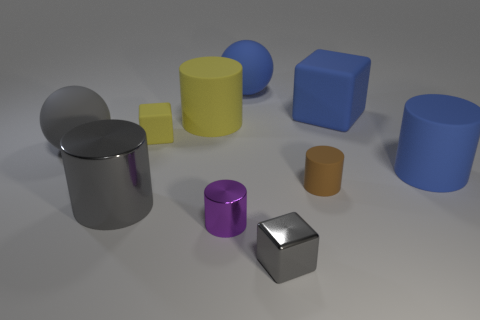Subtract all red cylinders. Subtract all green blocks. How many cylinders are left? 5 Subtract all balls. How many objects are left? 8 Add 1 large yellow cylinders. How many large yellow cylinders exist? 2 Subtract 1 blue blocks. How many objects are left? 9 Subtract all big metal cubes. Subtract all yellow rubber objects. How many objects are left? 8 Add 7 small cubes. How many small cubes are left? 9 